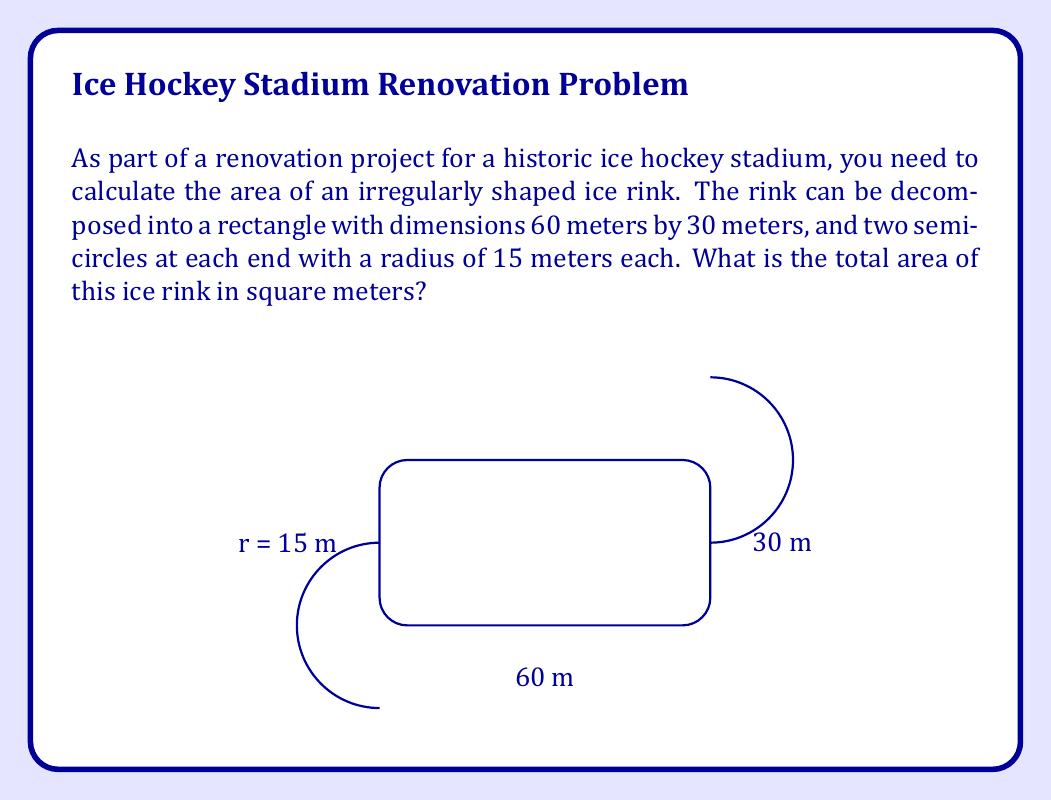Can you solve this math problem? To solve this problem, we'll break it down into steps:

1) First, calculate the area of the rectangular portion:
   $$A_{rectangle} = length \times width = 60 \text{ m} \times 30 \text{ m} = 1800 \text{ m}^2$$

2) Next, calculate the area of one semicircle:
   $$A_{semicircle} = \frac{1}{2} \times \pi r^2 = \frac{1}{2} \times \pi \times (15 \text{ m})^2 = \frac{225\pi}{2} \text{ m}^2$$

3) Since there are two identical semicircles, multiply this by 2:
   $$A_{both semicircles} = 2 \times \frac{225\pi}{2} \text{ m}^2 = 225\pi \text{ m}^2$$

4) The total area is the sum of the rectangle and both semicircles:
   $$A_{total} = A_{rectangle} + A_{both semicircles} = 1800 \text{ m}^2 + 225\pi \text{ m}^2$$

5) Simplify:
   $$A_{total} = (1800 + 225\pi) \text{ m}^2 \approx 2506.86 \text{ m}^2$$

Therefore, the total area of the ice rink is $(1800 + 225\pi)$ square meters, or approximately 2506.86 square meters.
Answer: $(1800 + 225\pi)$ m² 